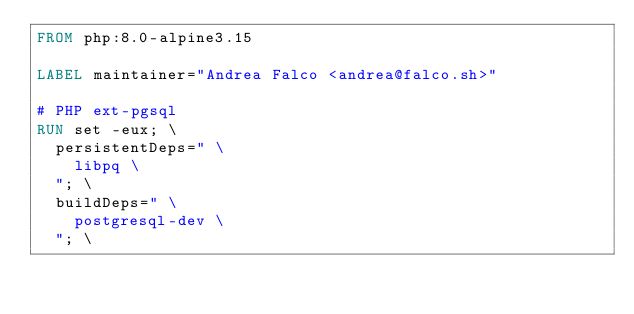<code> <loc_0><loc_0><loc_500><loc_500><_Dockerfile_>FROM php:8.0-alpine3.15

LABEL maintainer="Andrea Falco <andrea@falco.sh>"

# PHP ext-pgsql
RUN set -eux; \
  persistentDeps=" \
    libpq \
  "; \
  buildDeps=" \
    postgresql-dev \
  "; \</code> 